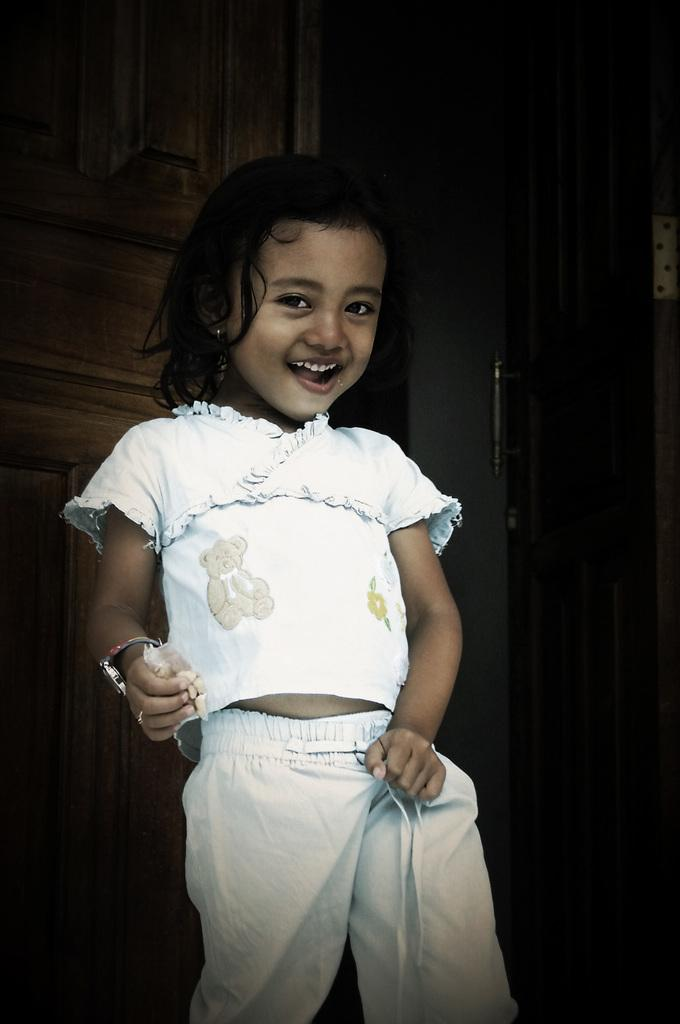Who is the main subject in the image? There is a girl in the image. What is the girl holding in her hand? The girl is holding a polythene cover in her hand. What type of paste is the girl using to stick the fruit in the image? There is no paste or fruit present in the image; the girl is only holding a polythene cover. What religion is the girl practicing in the image? There is no indication of the girl's religion in the image. 